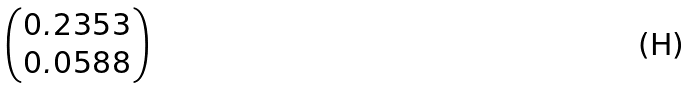Convert formula to latex. <formula><loc_0><loc_0><loc_500><loc_500>\begin{pmatrix} 0 . 2 3 5 3 \\ 0 . 0 5 8 8 \end{pmatrix}</formula> 